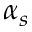<formula> <loc_0><loc_0><loc_500><loc_500>\alpha _ { s }</formula> 